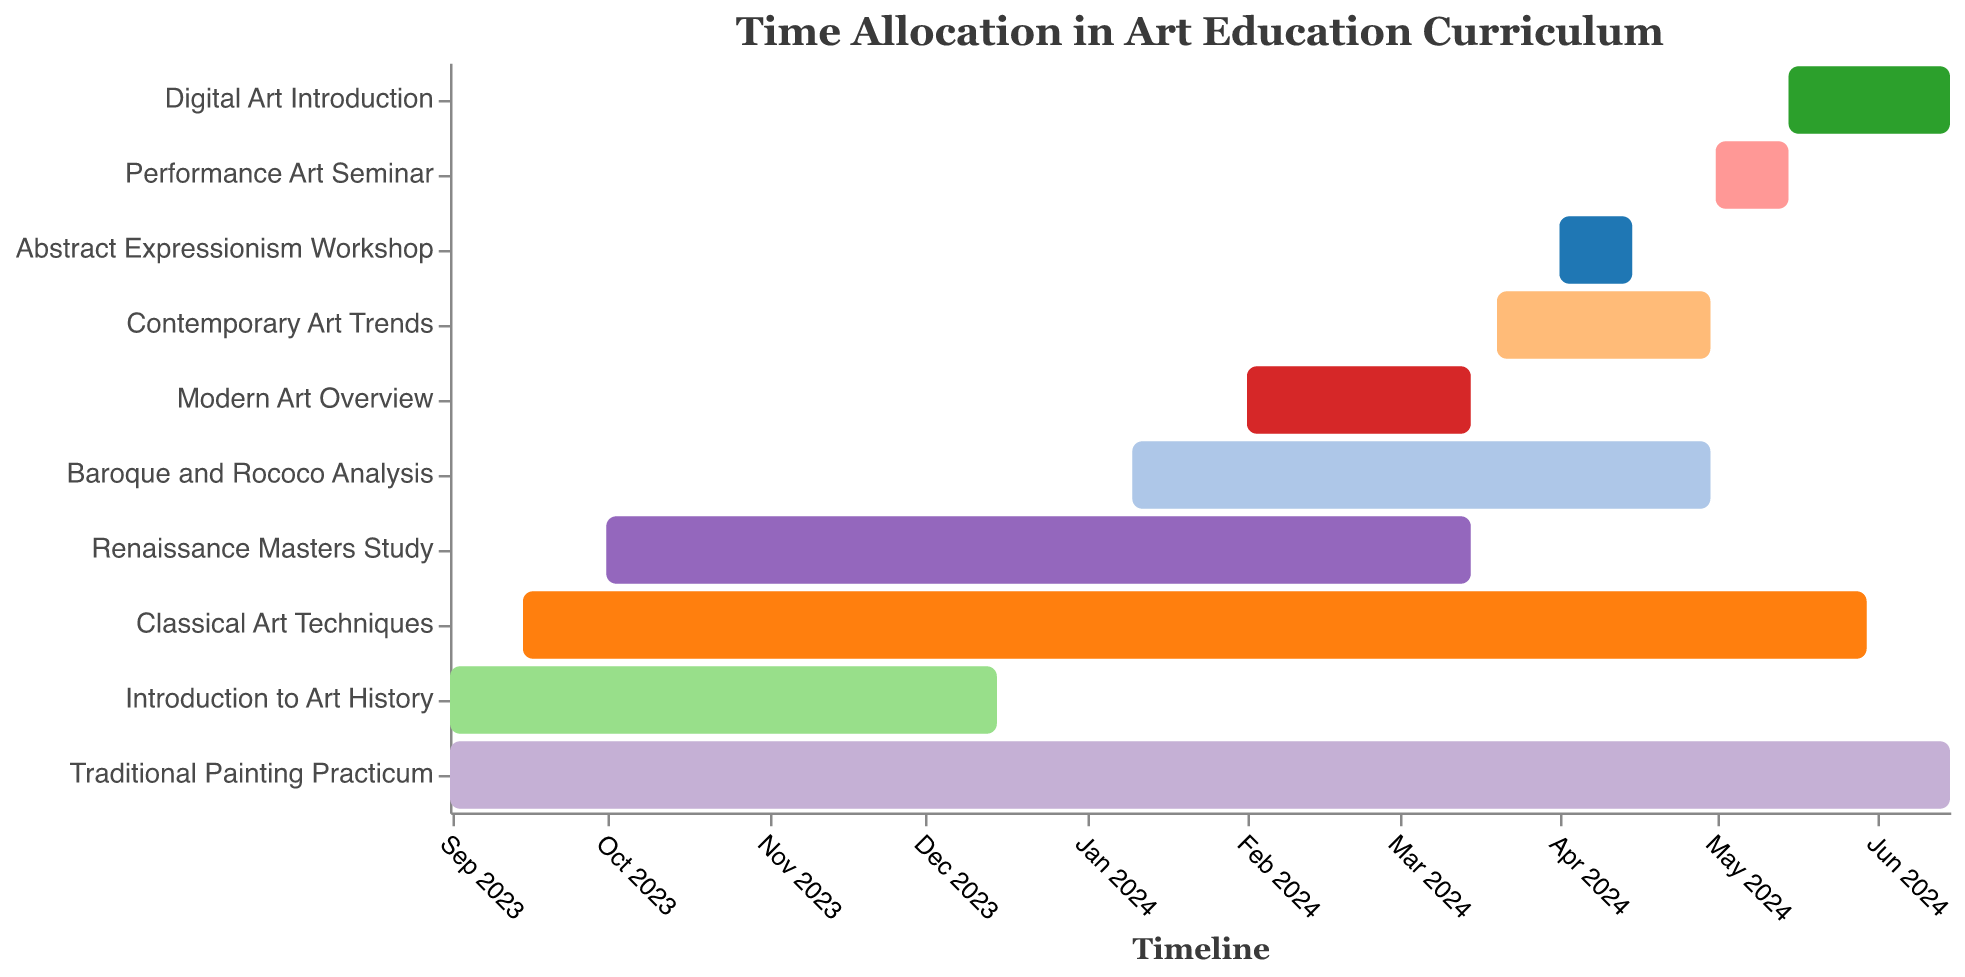What is the title of the figure? The title of the figure is usually displayed at the top and provides an overview of what the chart represents. In this case, the title indicates the main focus of the Gantt Chart.
Answer: Time Allocation in Art Education Curriculum Which task has the longest duration? To find out which task has the longest duration, we need to compare the start and end dates of each task in the chart and see which one spans the most days.
Answer: Traditional Painting Practicum When does the 'Classical Art Techniques' task start and end? Look at the horizontal position of the 'Classical Art Techniques' bar in relation to the timeline at the bottom of the chart. These positions should show both start and end dates.
Answer: Starts on September 15, 2023, and ends on May 30, 2024 Which tasks are conducted concurrently with 'Introduction to Art History'? Identify the timeline of 'Introduction to Art History' and then check for any other tasks with overlapping timelines during this period.
Answer: Classical Art Techniques and Traditional Painting Practicum Compare the duration between 'Contemporary Art Trends' and 'Modern Art Overview'. Which one is longer? Measure the duration for each task by looking at the start and end dates and then comparing the lengths of the bars on the chart.
Answer: Contemporary Art Trends is longer In what month does 'Baroque and Rococo Analysis' end? Find the end of the bar for 'Baroque and Rococo Analysis' and note the corresponding month on the timeline.
Answer: April 2024 How many tasks conclude in June 2024? Check the end of each bar to see which ones fall in June 2024. Count these tasks.
Answer: Two tasks What is the average duration of all tasks? Calculate the duration for each task, add them together, and then divide by the total number of tasks. First, find each duration in days, sum them, and then compute the average.
Answer: 172.5 days Which tasks run entirely within 2024? Look at the bars with start and end dates both within 2024. Verify the total duration fits in the year.
Answer: Baroque and Rococo Analysis, Modern Art Overview, Contemporary Art Trends, Abstract Expressionism Workshop, Performance Art Seminar, Digital Art Introduction What is the shortest task in terms of duration? Compare the length of all bars visually and check for the shortest end-to-end duration on the chart.
Answer: Abstract Expressionism Workshop 